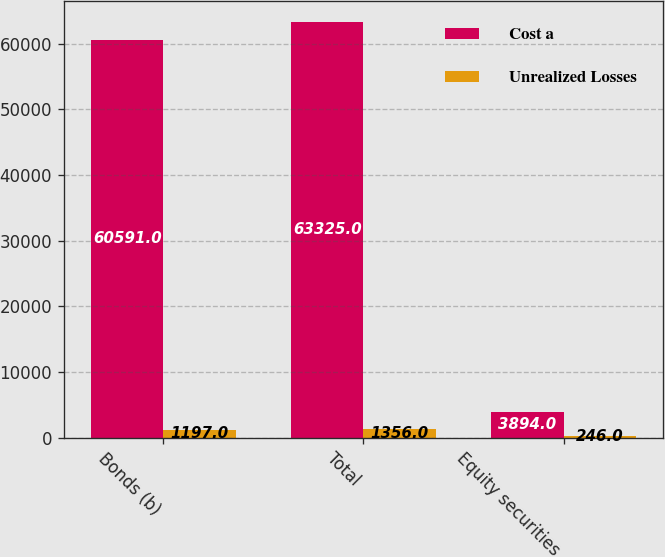<chart> <loc_0><loc_0><loc_500><loc_500><stacked_bar_chart><ecel><fcel>Bonds (b)<fcel>Total<fcel>Equity securities<nl><fcel>Cost a<fcel>60591<fcel>63325<fcel>3894<nl><fcel>Unrealized Losses<fcel>1197<fcel>1356<fcel>246<nl></chart> 